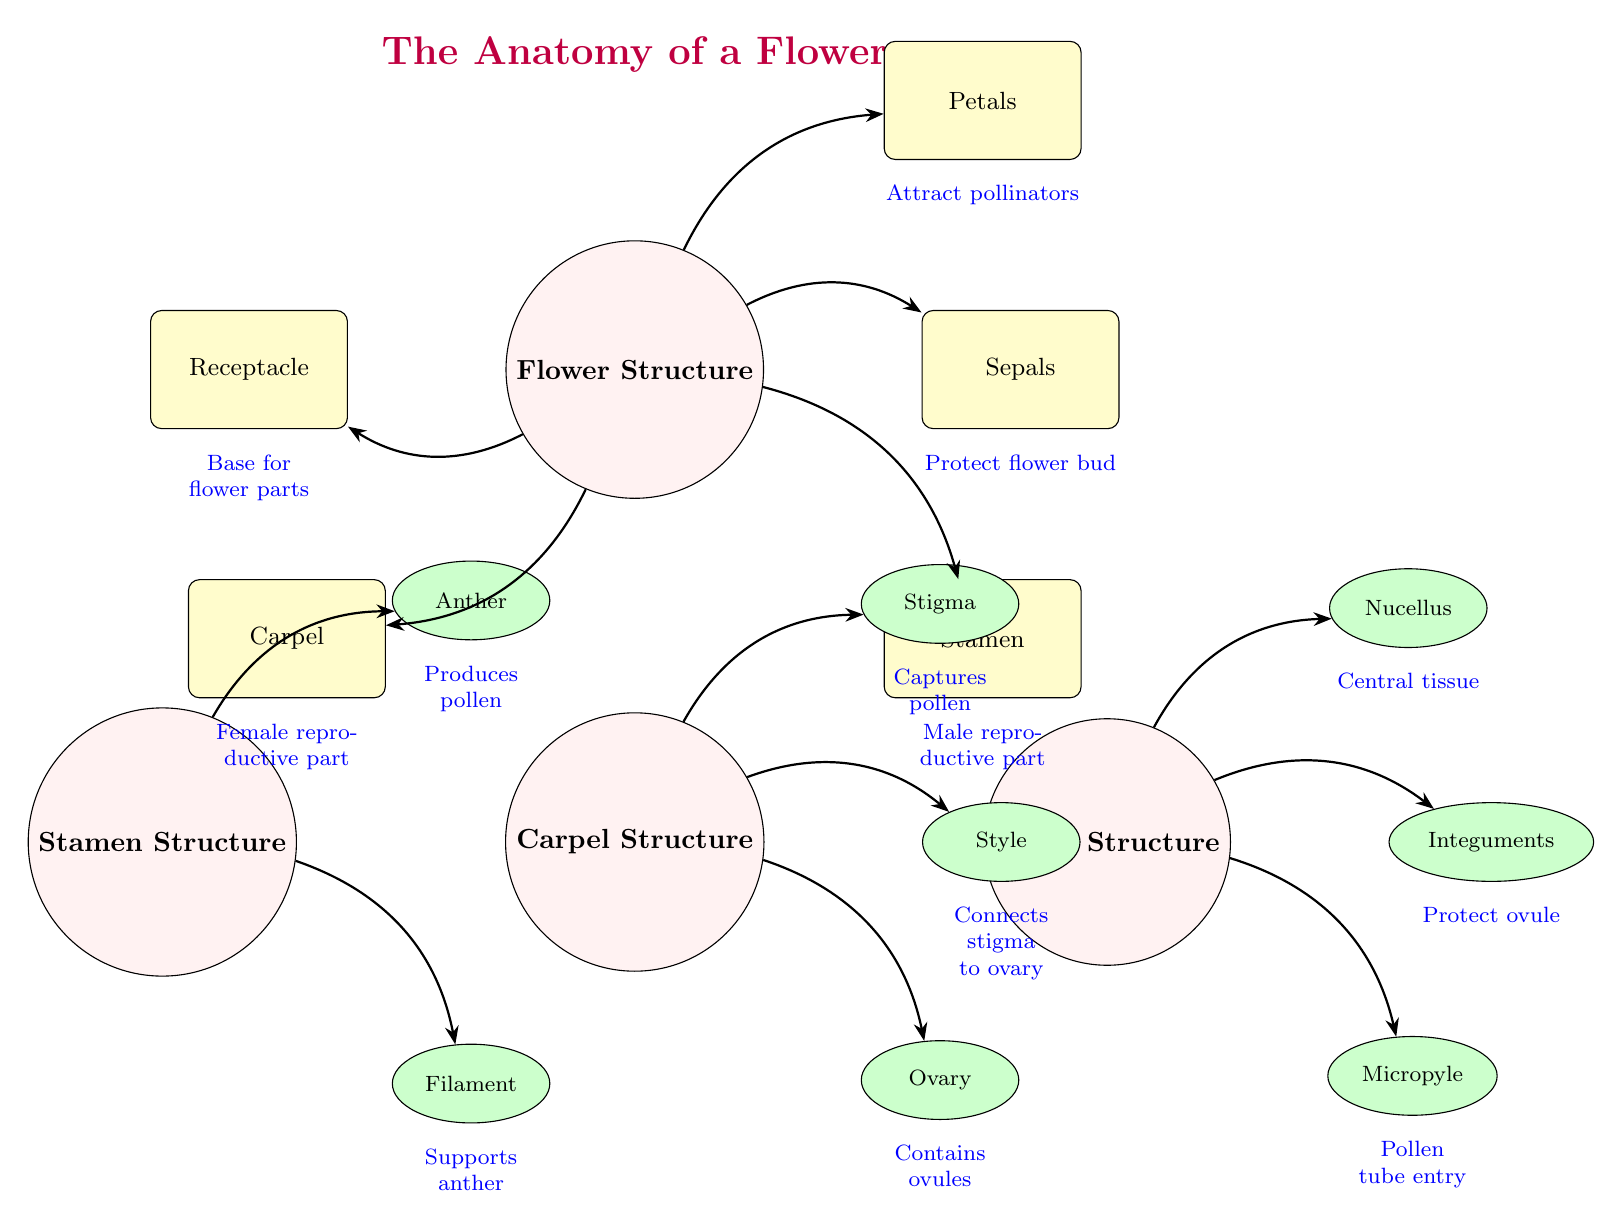What are the main parts of the flower structure? The diagram shows five main components under "Flower Structure": Petals, Sepals, Stamen, Carpel, and Receptacle.
Answer: Petals, Sepals, Stamen, Carpel, Receptacle What is the function of the stigma? According to the diagram, the stigma is described as capturing pollen, which is its primary function.
Answer: Captures pollen How many components are in the carpel structure? The carpel structure consists of three components: Stigma, Style, and Ovary, as indicated in the diagram.
Answer: 3 What does the filament do? The diagram specifies that the filament's function is to support the anther, linking structure to function.
Answer: Supports anther What do integuments protect? From the diagram, it is stated that integuments protect the ovule, pertaining to their structural role.
Answer: Ovule What is the relationship between the anther and filament? The diagram shows a direct connection indicating that both are part of the stamen, where the anther is the pollen-producing part, supported by the filament.
Answer: Part of the stamen Which part of the flower structure attracts pollinators? The diagram clearly states that the petal's function is to attract pollinators, highlighting its ecological role.
Answer: Petals What is the connection type from carpel to ovary? The diagram utilizes an arrow to indicate that the carpel structurally leads to the ovary, illustrating the flow from reproductive structure to hormonal or biological function.
Answer: Arrow connection What is below the style in the carpel structure? The diagram indicates the ovary is directly below the style, which is part of the vertical hierarchy of the carpel's anatomy.
Answer: Ovary 